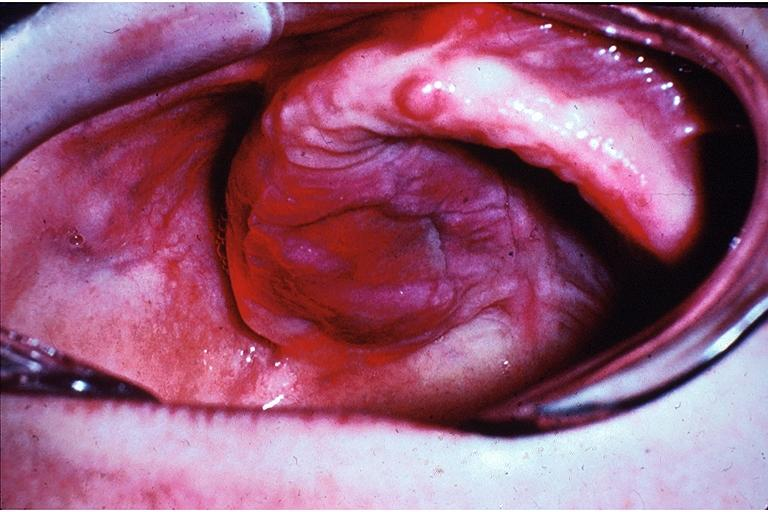where is this?
Answer the question using a single word or phrase. Oral 